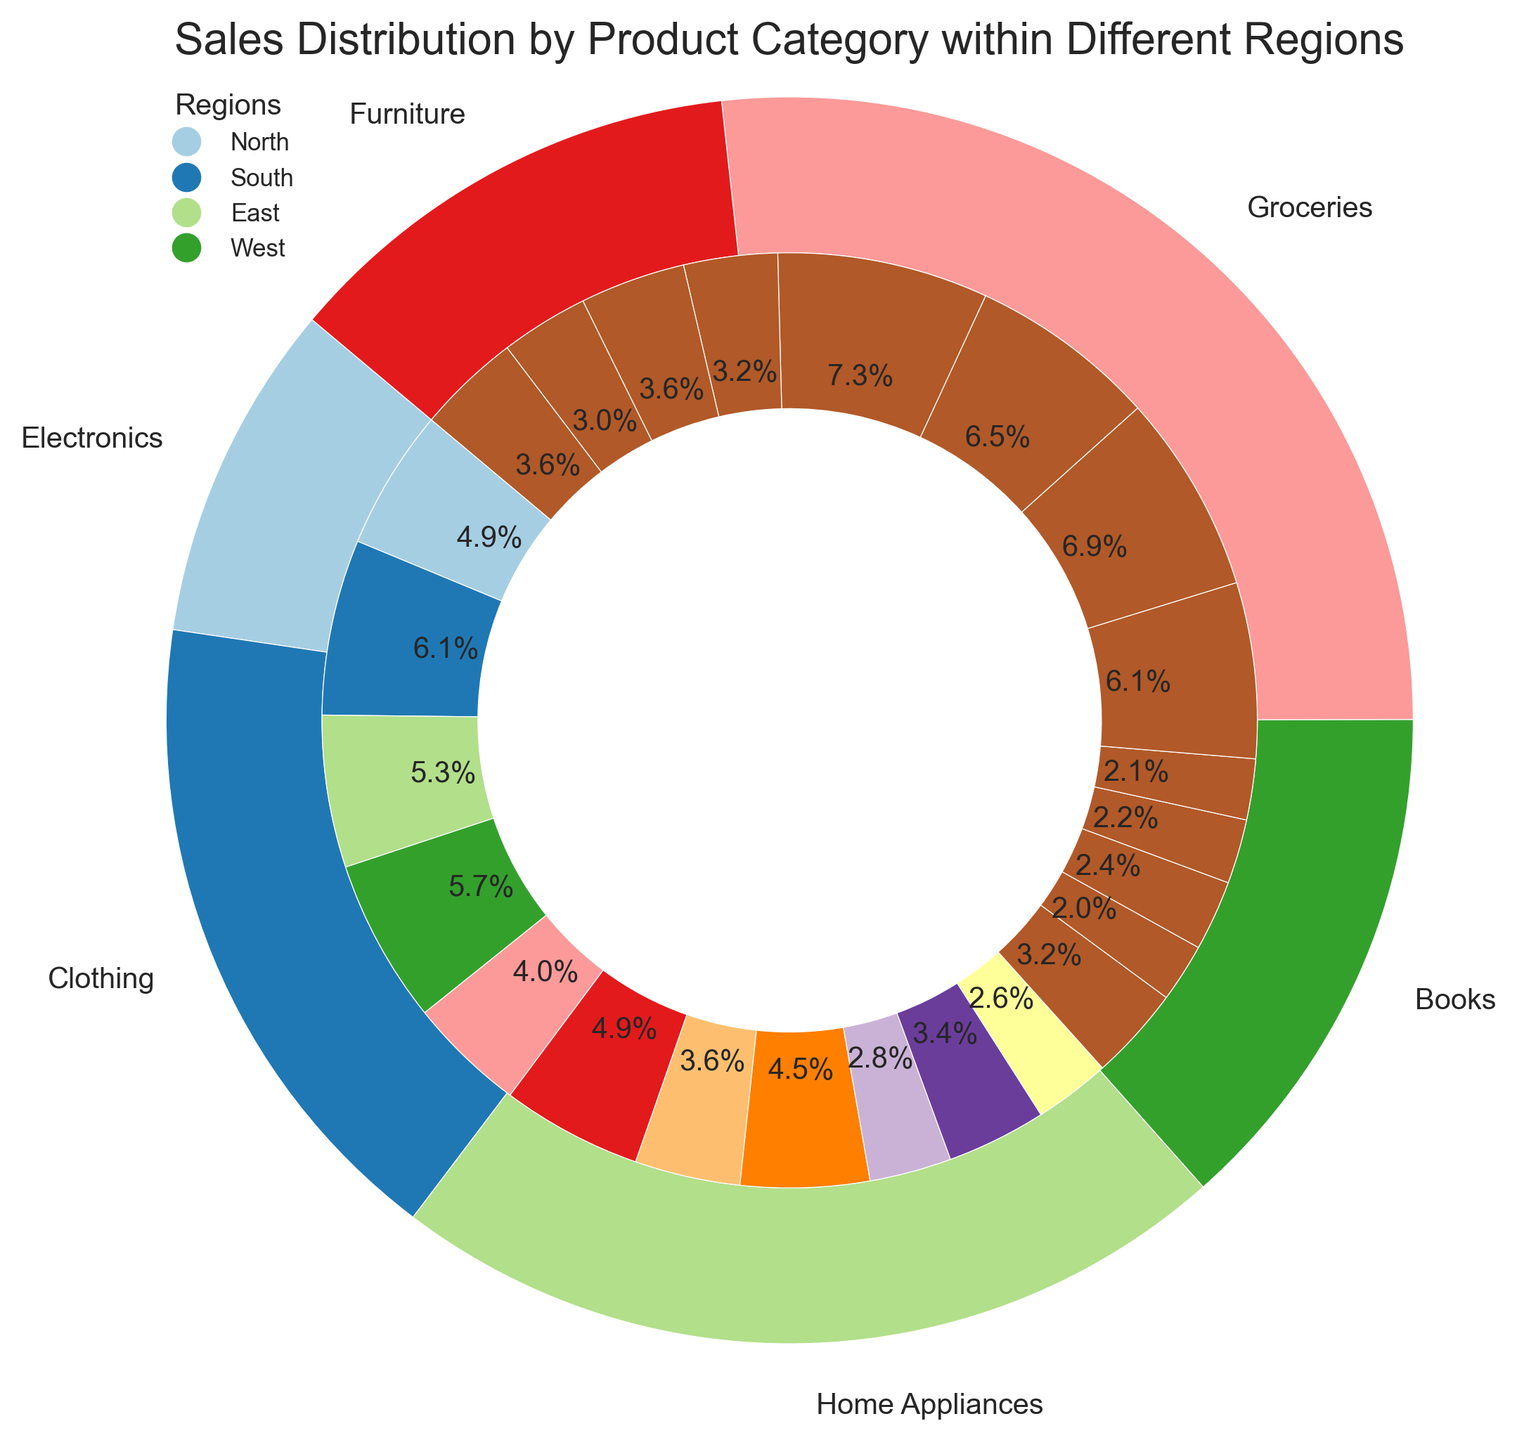Which product category has the highest sales in the North region? Look at the inner pie connected to the 'North' region in the outer pie. Groceries have the largest slice among the segments representing the North region.
Answer: Groceries How do the sales of Electronics in the South compare to the sales of Clothing in the same region? Locate the inner pie sections for Electronics and Clothing within the South region. The slice for Electronics ($15,000) is larger than that for Clothing ($12,000).
Answer: Electronics have higher sales What is the total sales for Home Appliances in all regions? Sum the sales for Home Appliances from the inner pie slices: $7,000 (North) + $8,500 (South) + $6,500 (East) + $8,000 (West). When combined, these total $30,000.
Answer: $30,000 Compare the sales distribution of Furniture and Books across all regions. Which category has more consistent sales? Compare the sizes of inner pie slices for Furniture and Books across all regions. Furniture slices are relatively even in size compared to Books, indicating more consistent sales.
Answer: Furniture Which region has the smallest contribution to the total sales of Groceries? Look at the inner pie representing Groceries. The 'East' segment, while larger than other regions in some categories, is smaller here compared to other regions within Groceries.
Answer: East What's the combined sales of Electronics and Home Appliances in the East region? Sum the sales of Electronics ($13,000) and Home Appliances ($6,500) for the East region. Adding these amounts gives a total of $19,500.
Answer: $19,500 Which product category has the smallest sales in the West region? Find the smallest inner pie slice connected to the 'West' region. Books have the smallest segment in this region.
Answer: Books How does the sales of Groceries in the South region compare to the average sales of all categories in the same region? Calculate the average sales for all categories in the South: Sum all South region sales: $15,000 (Electronics) + $12,000 (Clothing) + $8,500 (Home Appliances) + $6,000 (Books) + $17,000 (Groceries) + $9,000 (Furniture) = $67,500. Average is $67,500 / 6. Compare this to Groceries ($17,000). The average sales are $11,250, which is less than Groceries.
Answer: Groceries have higher sales What percentage of total sales for Electronics is contributed by the West region? Sum the total sales for Electronics across all regions: $12,000 (North) + $15,000 (South) + $13,000 (East) + $14,000 (West) = $54,000. Percentage contribution from the West is ($14,000 / $54,000) x 100 ≈ 25.9%.
Answer: 25.9% Among all regions, which one contributes the most to Furniture sales? Check the inner pie slices representing Furniture for each region. The largest slice is from the South region ($9000).
Answer: South 